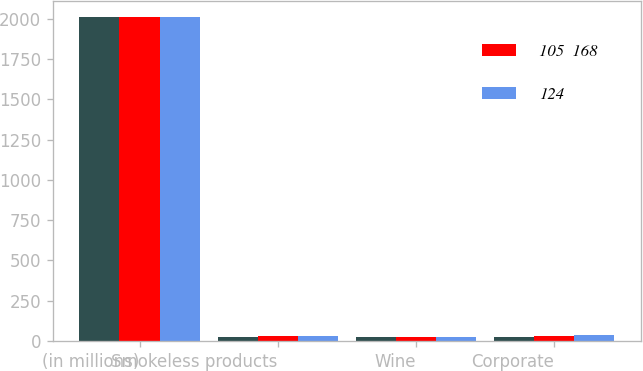Convert chart to OTSL. <chart><loc_0><loc_0><loc_500><loc_500><stacked_bar_chart><ecel><fcel>(in millions)<fcel>Smokeless products<fcel>Wine<fcel>Corporate<nl><fcel>nan<fcel>2012<fcel>26<fcel>27<fcel>27<nl><fcel>105  168<fcel>2011<fcel>31<fcel>25<fcel>32<nl><fcel>124<fcel>2010<fcel>32<fcel>23<fcel>34<nl></chart> 